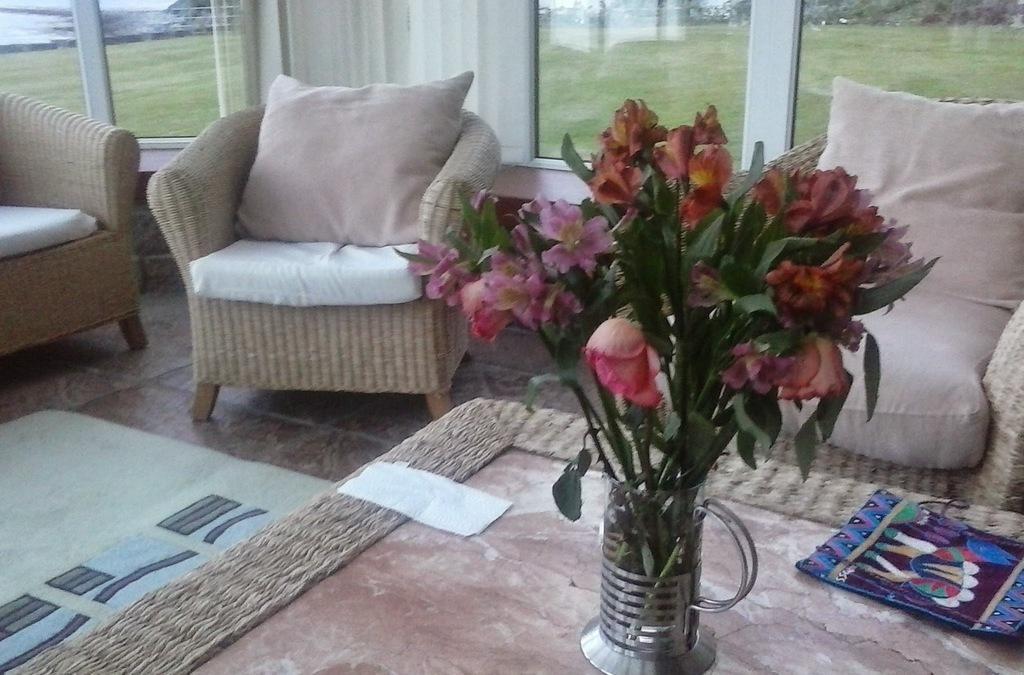Can you describe this image briefly? These are the sofa chairs and a flower vase on the table outside the window there is a grass. 